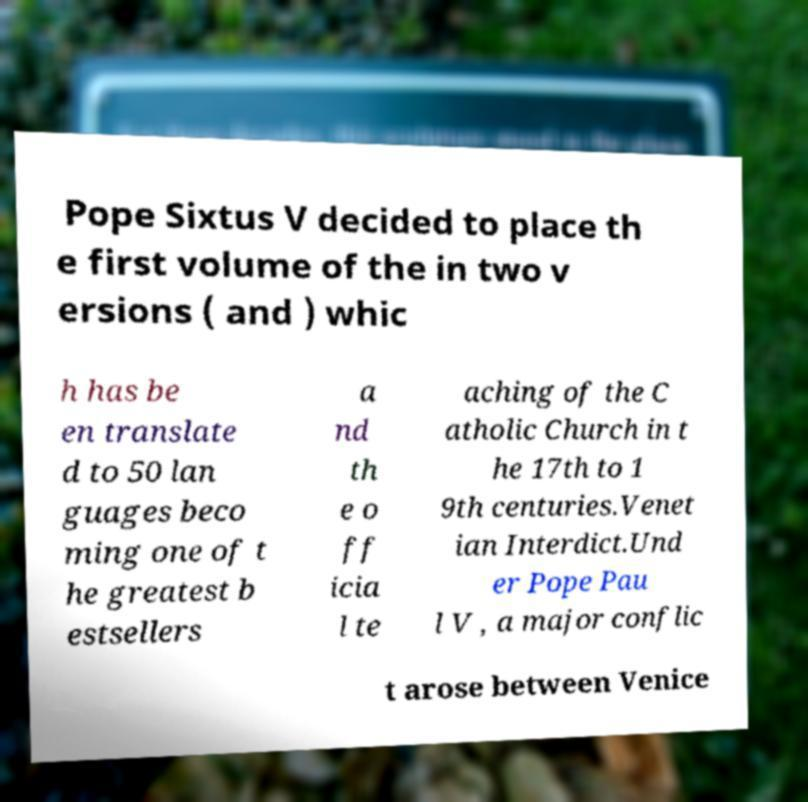Could you extract and type out the text from this image? Pope Sixtus V decided to place th e first volume of the in two v ersions ( and ) whic h has be en translate d to 50 lan guages beco ming one of t he greatest b estsellers a nd th e o ff icia l te aching of the C atholic Church in t he 17th to 1 9th centuries.Venet ian Interdict.Und er Pope Pau l V , a major conflic t arose between Venice 